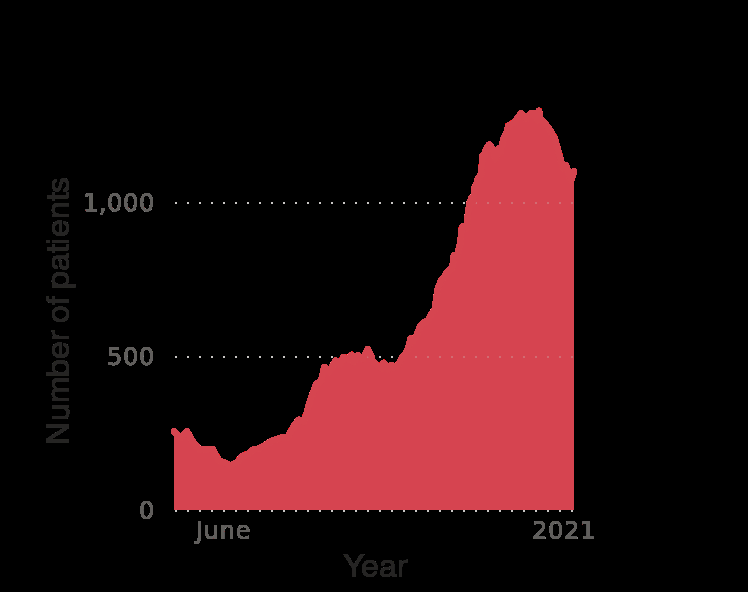<image>
What is the data being plotted on the y-axis?  The data being plotted on the y-axis is the number of patients in critical condition infected with the coronavirus (COVID-19) in Romania.  What is the pattern of numbers before a steep upwards climb? The pattern of numbers is variable before a steep upwards climb. What is the time period shown on the x-axis?  The time period shown on the x-axis is from June to 2021. 